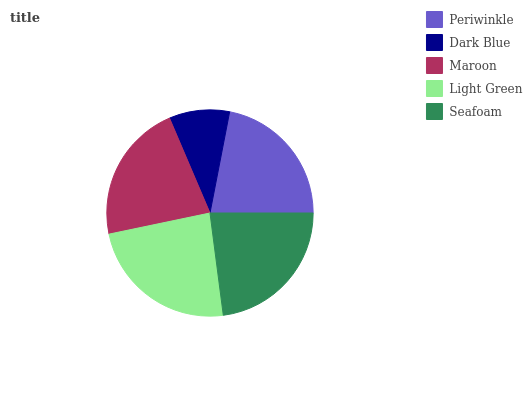Is Dark Blue the minimum?
Answer yes or no. Yes. Is Light Green the maximum?
Answer yes or no. Yes. Is Maroon the minimum?
Answer yes or no. No. Is Maroon the maximum?
Answer yes or no. No. Is Maroon greater than Dark Blue?
Answer yes or no. Yes. Is Dark Blue less than Maroon?
Answer yes or no. Yes. Is Dark Blue greater than Maroon?
Answer yes or no. No. Is Maroon less than Dark Blue?
Answer yes or no. No. Is Periwinkle the high median?
Answer yes or no. Yes. Is Periwinkle the low median?
Answer yes or no. Yes. Is Light Green the high median?
Answer yes or no. No. Is Seafoam the low median?
Answer yes or no. No. 